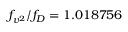Convert formula to latex. <formula><loc_0><loc_0><loc_500><loc_500>f _ { v ^ { 2 } } / f _ { D } = 1 . 0 1 8 7 5 6</formula> 